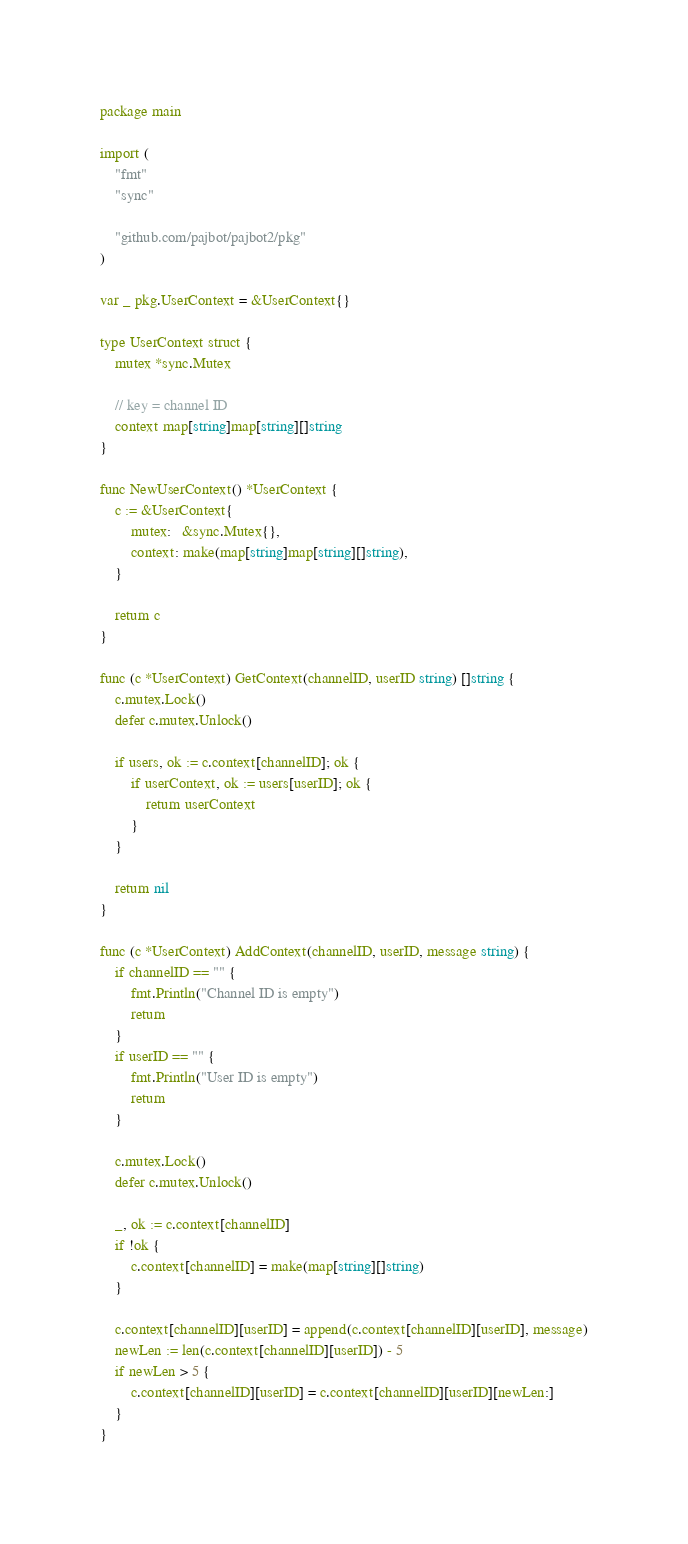<code> <loc_0><loc_0><loc_500><loc_500><_Go_>package main

import (
	"fmt"
	"sync"

	"github.com/pajbot/pajbot2/pkg"
)

var _ pkg.UserContext = &UserContext{}

type UserContext struct {
	mutex *sync.Mutex

	// key = channel ID
	context map[string]map[string][]string
}

func NewUserContext() *UserContext {
	c := &UserContext{
		mutex:   &sync.Mutex{},
		context: make(map[string]map[string][]string),
	}

	return c
}

func (c *UserContext) GetContext(channelID, userID string) []string {
	c.mutex.Lock()
	defer c.mutex.Unlock()

	if users, ok := c.context[channelID]; ok {
		if userContext, ok := users[userID]; ok {
			return userContext
		}
	}

	return nil
}

func (c *UserContext) AddContext(channelID, userID, message string) {
	if channelID == "" {
		fmt.Println("Channel ID is empty")
		return
	}
	if userID == "" {
		fmt.Println("User ID is empty")
		return
	}

	c.mutex.Lock()
	defer c.mutex.Unlock()

	_, ok := c.context[channelID]
	if !ok {
		c.context[channelID] = make(map[string][]string)
	}

	c.context[channelID][userID] = append(c.context[channelID][userID], message)
	newLen := len(c.context[channelID][userID]) - 5
	if newLen > 5 {
		c.context[channelID][userID] = c.context[channelID][userID][newLen:]
	}
}
</code> 